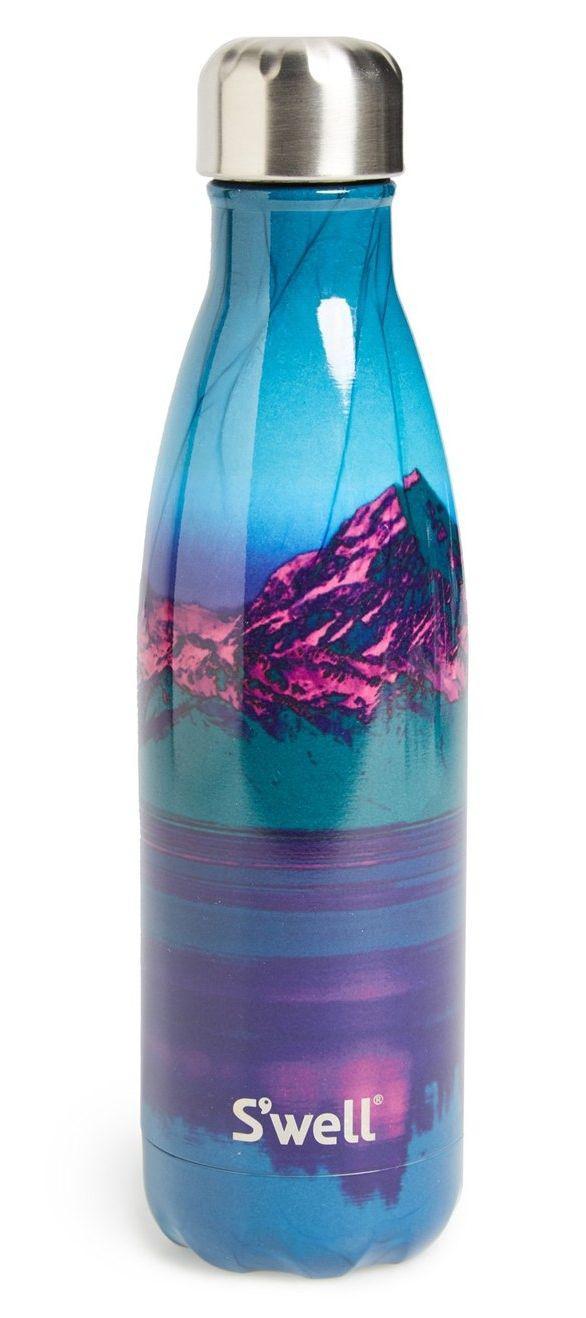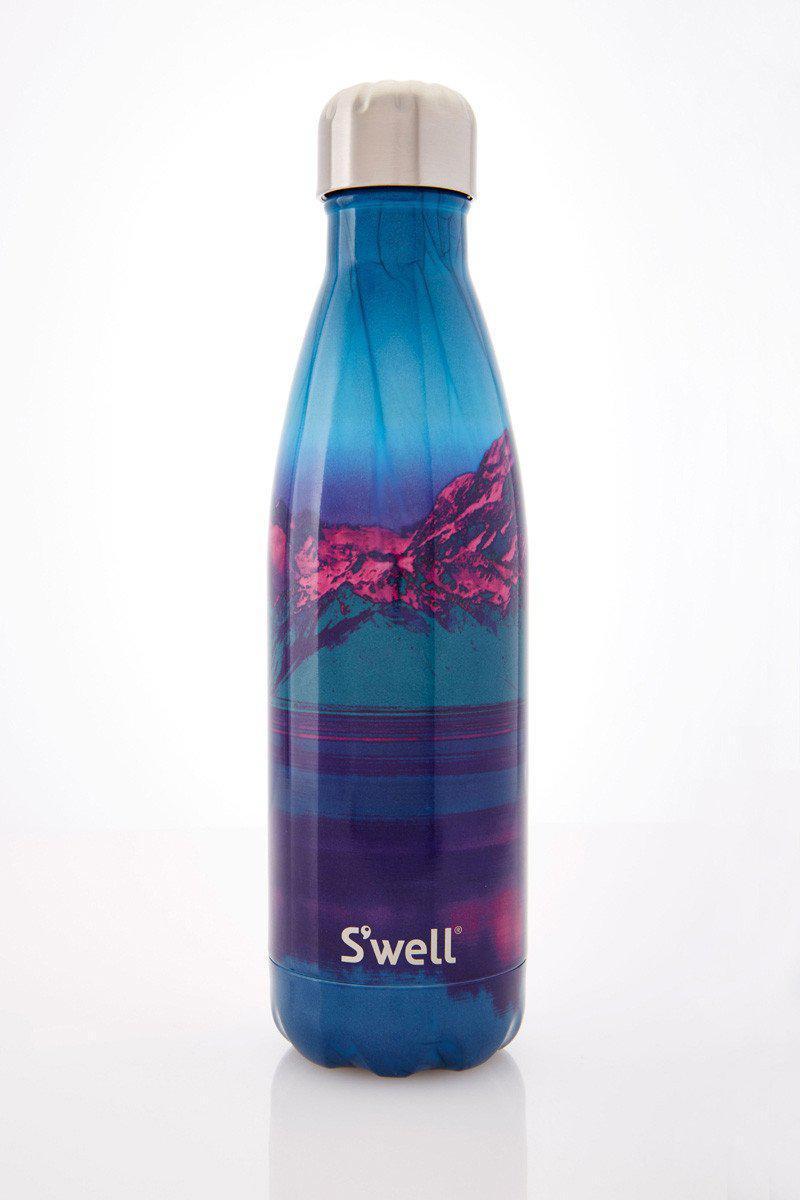The first image is the image on the left, the second image is the image on the right. Evaluate the accuracy of this statement regarding the images: "The image on the left contains a dark blue bottle.". Is it true? Answer yes or no. No. 